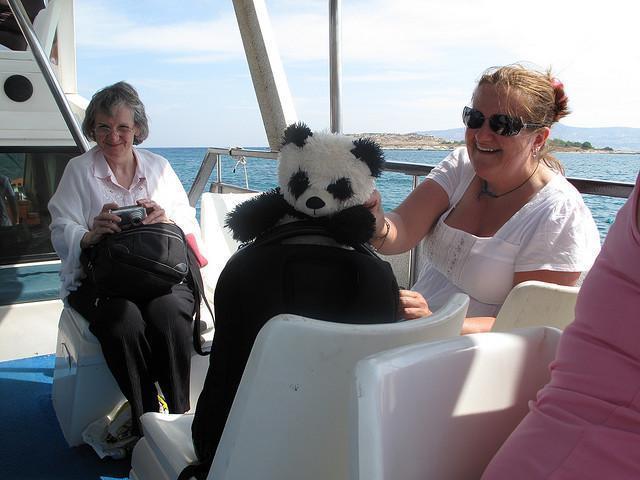What digital device is being used to capture memories?
From the following set of four choices, select the accurate answer to respond to the question.
Options: Recorder, phone, sketch artist, camera. Camera. 